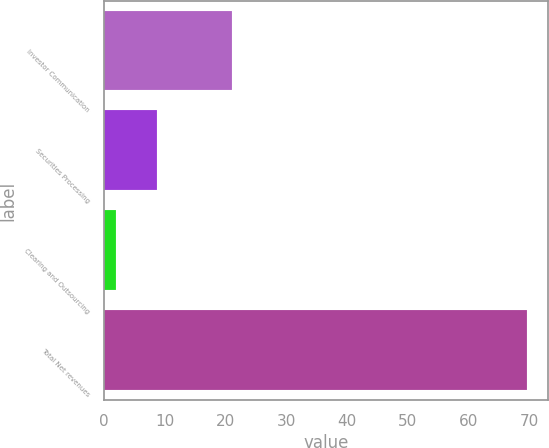<chart> <loc_0><loc_0><loc_500><loc_500><bar_chart><fcel>Investor Communication<fcel>Securities Processing<fcel>Clearing and Outsourcing<fcel>Total Net revenues<nl><fcel>21<fcel>8.76<fcel>2<fcel>69.6<nl></chart> 